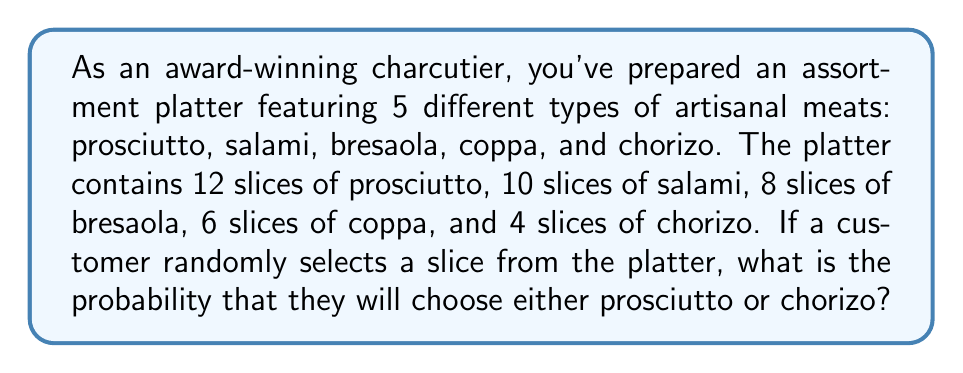Show me your answer to this math problem. To solve this problem, we need to follow these steps:

1. Calculate the total number of slices on the platter:
   $$ \text{Total slices} = 12 + 10 + 8 + 6 + 4 = 40 $$

2. Identify the number of favorable outcomes (prosciutto or chorizo slices):
   $$ \text{Favorable outcomes} = 12 \text{ (prosciutto)} + 4 \text{ (chorizo)} = 16 $$

3. Apply the probability formula:
   $$ P(\text{event}) = \frac{\text{number of favorable outcomes}}{\text{total number of possible outcomes}} $$

4. Substitute the values:
   $$ P(\text{prosciutto or chorizo}) = \frac{16}{40} $$

5. Simplify the fraction:
   $$ P(\text{prosciutto or chorizo}) = \frac{2}{5} = 0.4 $$

Thus, the probability of a customer selecting either prosciutto or chorizo is $\frac{2}{5}$ or 0.4 or 40%.
Answer: $\frac{2}{5}$ or 0.4 or 40% 